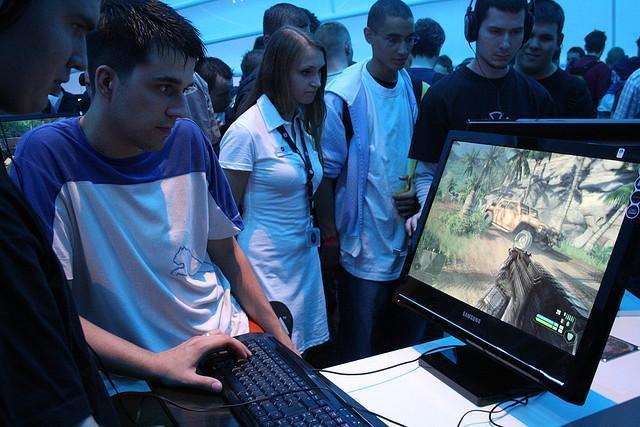What are the two men watching?
Choose the right answer and clarify with the format: 'Answer: answer
Rationale: rationale.'
Options: News report, video game, movie, music video. Answer: video game.
Rationale: The two men are watching a screen showing a video game. 